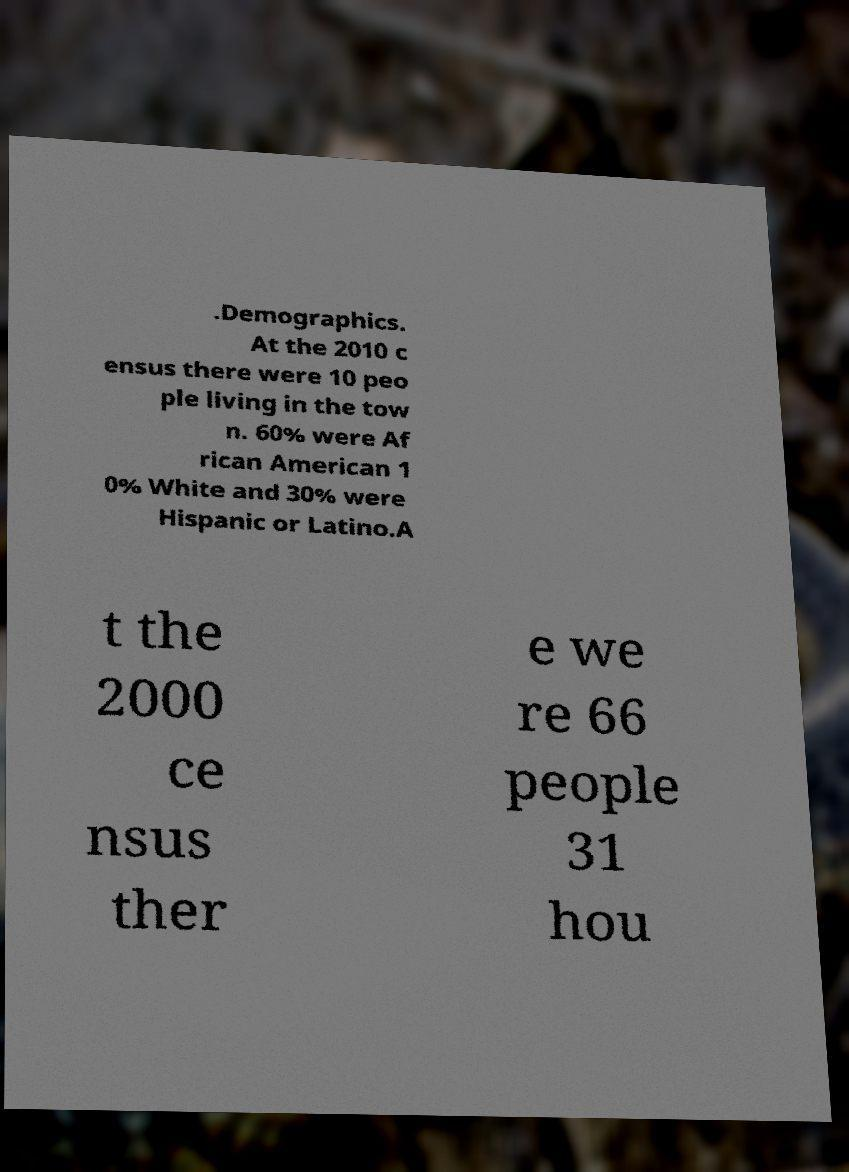For documentation purposes, I need the text within this image transcribed. Could you provide that? .Demographics. At the 2010 c ensus there were 10 peo ple living in the tow n. 60% were Af rican American 1 0% White and 30% were Hispanic or Latino.A t the 2000 ce nsus ther e we re 66 people 31 hou 